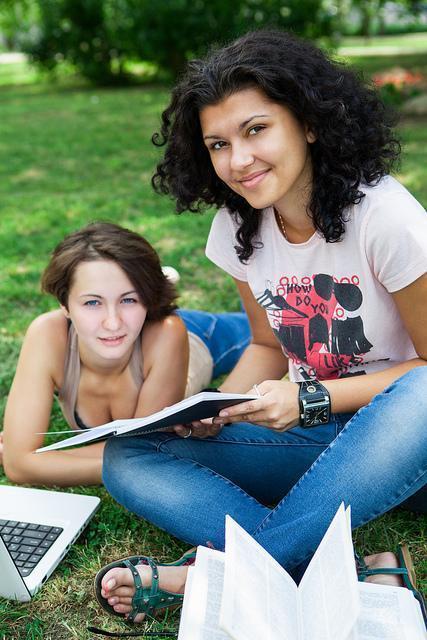How many books are in the photo?
Give a very brief answer. 2. How many people are visible?
Give a very brief answer. 2. 